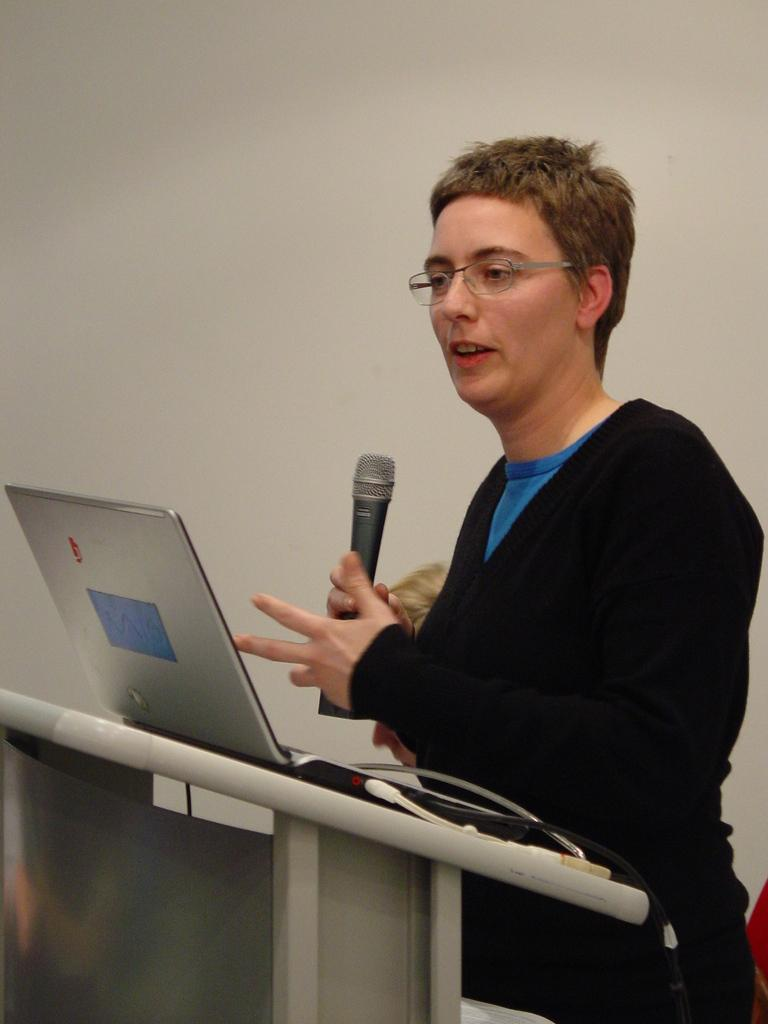Who or what is the main subject in the image? There is a person in the image. What is the person wearing? The person is wearing a black jacket. What is the person holding? The person is holding a mic. What is in front of the person? There is a podium in front of the person. What is on the podium? A mic and a laptop are on the podium. What can be seen in the background of the image? There is a wall in the background of the image. Can you see a crown on the person's head in the image? No, there is no crown visible on the person's head in the image. 